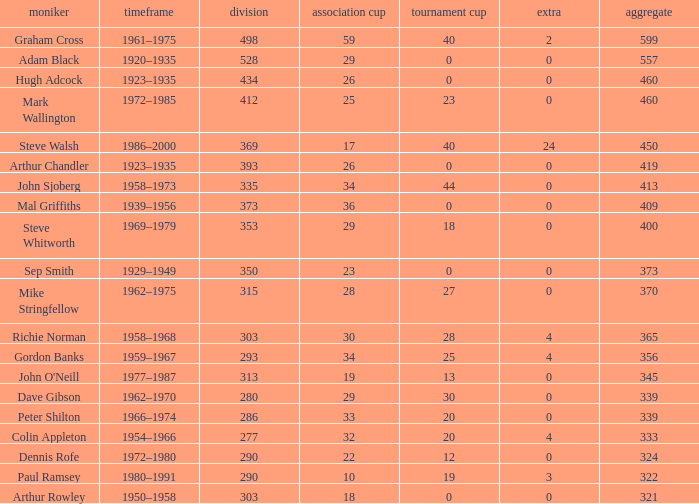What is the lowest number of League Cups a player with a 434 league has? 0.0. 